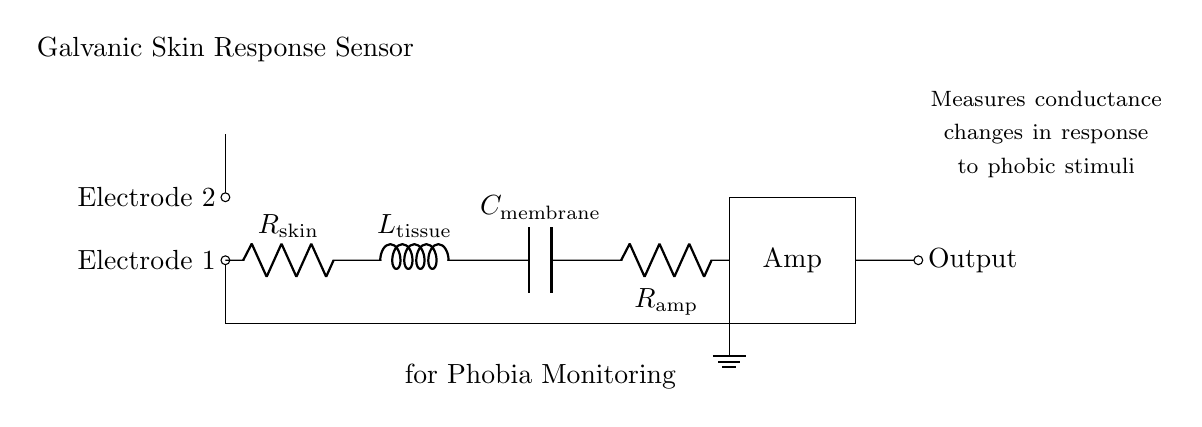What are the components in this circuit? The circuit consists of two electrodes, a resistor (R skin), an inductor (L tissue), a capacitor (C membrane), and another resistor (R amp). These components are connected in series.
Answer: Two electrodes, R skin, L tissue, C membrane, R amp What is the role of the electrodes? The electrodes detect the galvanic skin response by measuring changes in electrical conductance of the skin due to phobic stimuli. They convert physiological changes into electrical signals.
Answer: Detect galvanic skin response What type of circuit is this? This is a series RLC circuit, which includes resistors, an inductor, and a capacitor configured in a single continuous pathway.
Answer: Series RLC circuit How does the inductor contribute to the circuit? The inductor (L tissue) reacts to changes in current by storing energy in a magnetic field, impacting the time response of the circuit in relation to conductance fluctuations caused by phobic reactions.
Answer: Stores energy in a magnetic field What effect does the capacitor have in the circuit? The capacitor (C membrane) stores electric charge and releases it, affecting the timing and smoothness of the voltage response to the changing conditions in the circuit due to phobic stimuli.
Answer: Stores and releases electric charge How does R amp function in this context? The resistor R amp amplifies the signal after it has been processed by the RLC components, ensuring that the output is significant enough to be measured or recorded after monitoring the skin response.
Answer: Amplifies the signal 